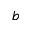Convert formula to latex. <formula><loc_0><loc_0><loc_500><loc_500>b</formula> 